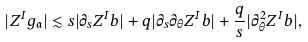Convert formula to latex. <formula><loc_0><loc_0><loc_500><loc_500>| Z ^ { I } { g _ { \mathfrak { a } } } | \lesssim s | \partial _ { s } Z ^ { I } b | + q | \partial _ { s } \partial _ { \theta } Z ^ { I } b | + \frac { q } { s } | \partial ^ { 2 } _ { \theta } Z ^ { I } b | ,</formula> 